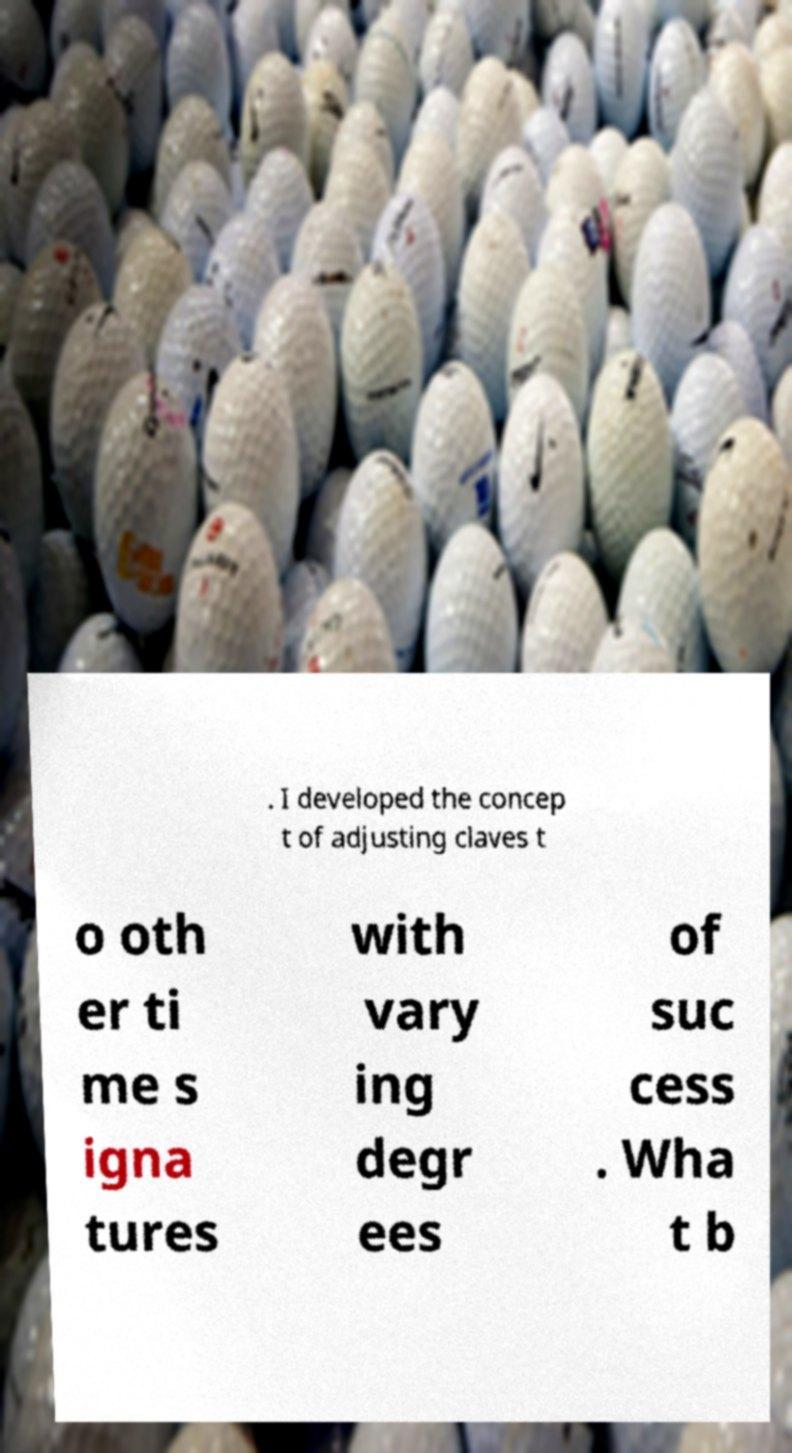Please read and relay the text visible in this image. What does it say? . I developed the concep t of adjusting claves t o oth er ti me s igna tures with vary ing degr ees of suc cess . Wha t b 